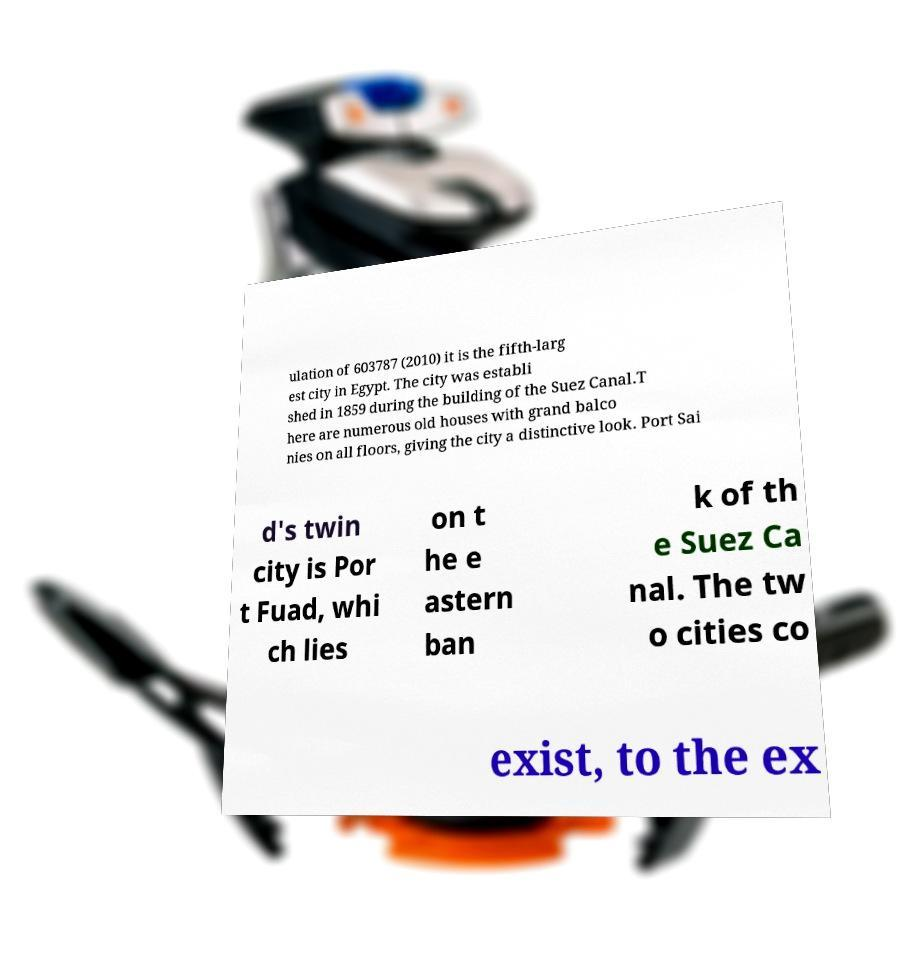Please read and relay the text visible in this image. What does it say? ulation of 603787 (2010) it is the fifth-larg est city in Egypt. The city was establi shed in 1859 during the building of the Suez Canal.T here are numerous old houses with grand balco nies on all floors, giving the city a distinctive look. Port Sai d's twin city is Por t Fuad, whi ch lies on t he e astern ban k of th e Suez Ca nal. The tw o cities co exist, to the ex 